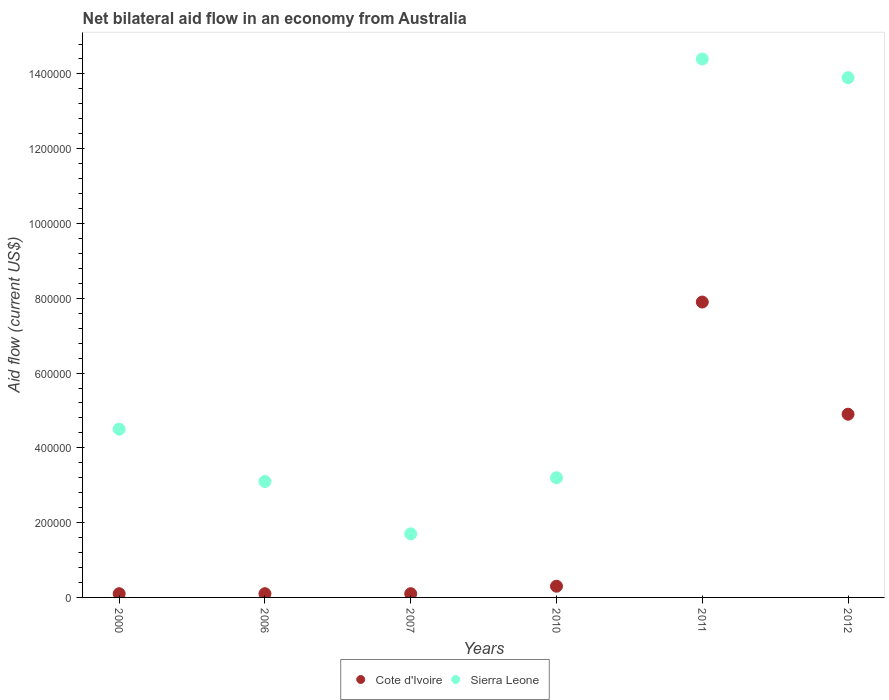Is the number of dotlines equal to the number of legend labels?
Keep it short and to the point. Yes. What is the net bilateral aid flow in Sierra Leone in 2011?
Your answer should be very brief. 1.44e+06. Across all years, what is the maximum net bilateral aid flow in Sierra Leone?
Provide a short and direct response. 1.44e+06. Across all years, what is the minimum net bilateral aid flow in Sierra Leone?
Offer a terse response. 1.70e+05. In which year was the net bilateral aid flow in Cote d'Ivoire maximum?
Offer a very short reply. 2011. What is the total net bilateral aid flow in Sierra Leone in the graph?
Offer a very short reply. 4.08e+06. What is the difference between the net bilateral aid flow in Sierra Leone in 2010 and that in 2011?
Provide a succinct answer. -1.12e+06. What is the difference between the net bilateral aid flow in Sierra Leone in 2010 and the net bilateral aid flow in Cote d'Ivoire in 2007?
Offer a very short reply. 3.10e+05. What is the average net bilateral aid flow in Cote d'Ivoire per year?
Your answer should be compact. 2.23e+05. In how many years, is the net bilateral aid flow in Cote d'Ivoire greater than 1280000 US$?
Provide a succinct answer. 0. What is the ratio of the net bilateral aid flow in Cote d'Ivoire in 2007 to that in 2012?
Ensure brevity in your answer.  0.02. What is the difference between the highest and the second highest net bilateral aid flow in Sierra Leone?
Give a very brief answer. 5.00e+04. What is the difference between the highest and the lowest net bilateral aid flow in Cote d'Ivoire?
Provide a succinct answer. 7.80e+05. Is the net bilateral aid flow in Cote d'Ivoire strictly greater than the net bilateral aid flow in Sierra Leone over the years?
Offer a very short reply. No. How many dotlines are there?
Keep it short and to the point. 2. How many years are there in the graph?
Offer a very short reply. 6. What is the difference between two consecutive major ticks on the Y-axis?
Offer a very short reply. 2.00e+05. Does the graph contain any zero values?
Provide a succinct answer. No. Does the graph contain grids?
Your answer should be compact. No. What is the title of the graph?
Ensure brevity in your answer.  Net bilateral aid flow in an economy from Australia. What is the Aid flow (current US$) in Cote d'Ivoire in 2000?
Offer a very short reply. 10000. What is the Aid flow (current US$) in Cote d'Ivoire in 2006?
Your answer should be very brief. 10000. What is the Aid flow (current US$) of Cote d'Ivoire in 2007?
Ensure brevity in your answer.  10000. What is the Aid flow (current US$) in Cote d'Ivoire in 2010?
Offer a very short reply. 3.00e+04. What is the Aid flow (current US$) in Sierra Leone in 2010?
Offer a terse response. 3.20e+05. What is the Aid flow (current US$) of Cote d'Ivoire in 2011?
Provide a short and direct response. 7.90e+05. What is the Aid flow (current US$) of Sierra Leone in 2011?
Keep it short and to the point. 1.44e+06. What is the Aid flow (current US$) in Cote d'Ivoire in 2012?
Give a very brief answer. 4.90e+05. What is the Aid flow (current US$) of Sierra Leone in 2012?
Offer a terse response. 1.39e+06. Across all years, what is the maximum Aid flow (current US$) of Cote d'Ivoire?
Offer a very short reply. 7.90e+05. Across all years, what is the maximum Aid flow (current US$) in Sierra Leone?
Keep it short and to the point. 1.44e+06. Across all years, what is the minimum Aid flow (current US$) in Sierra Leone?
Offer a terse response. 1.70e+05. What is the total Aid flow (current US$) in Cote d'Ivoire in the graph?
Offer a very short reply. 1.34e+06. What is the total Aid flow (current US$) of Sierra Leone in the graph?
Give a very brief answer. 4.08e+06. What is the difference between the Aid flow (current US$) of Cote d'Ivoire in 2000 and that in 2006?
Provide a succinct answer. 0. What is the difference between the Aid flow (current US$) of Sierra Leone in 2000 and that in 2006?
Offer a very short reply. 1.40e+05. What is the difference between the Aid flow (current US$) in Cote d'Ivoire in 2000 and that in 2007?
Provide a succinct answer. 0. What is the difference between the Aid flow (current US$) of Sierra Leone in 2000 and that in 2010?
Offer a very short reply. 1.30e+05. What is the difference between the Aid flow (current US$) in Cote d'Ivoire in 2000 and that in 2011?
Your answer should be very brief. -7.80e+05. What is the difference between the Aid flow (current US$) in Sierra Leone in 2000 and that in 2011?
Provide a succinct answer. -9.90e+05. What is the difference between the Aid flow (current US$) in Cote d'Ivoire in 2000 and that in 2012?
Give a very brief answer. -4.80e+05. What is the difference between the Aid flow (current US$) of Sierra Leone in 2000 and that in 2012?
Offer a very short reply. -9.40e+05. What is the difference between the Aid flow (current US$) in Cote d'Ivoire in 2006 and that in 2007?
Give a very brief answer. 0. What is the difference between the Aid flow (current US$) of Sierra Leone in 2006 and that in 2007?
Your answer should be compact. 1.40e+05. What is the difference between the Aid flow (current US$) of Cote d'Ivoire in 2006 and that in 2010?
Offer a very short reply. -2.00e+04. What is the difference between the Aid flow (current US$) of Cote d'Ivoire in 2006 and that in 2011?
Ensure brevity in your answer.  -7.80e+05. What is the difference between the Aid flow (current US$) of Sierra Leone in 2006 and that in 2011?
Ensure brevity in your answer.  -1.13e+06. What is the difference between the Aid flow (current US$) of Cote d'Ivoire in 2006 and that in 2012?
Provide a short and direct response. -4.80e+05. What is the difference between the Aid flow (current US$) in Sierra Leone in 2006 and that in 2012?
Your answer should be very brief. -1.08e+06. What is the difference between the Aid flow (current US$) in Cote d'Ivoire in 2007 and that in 2010?
Your answer should be compact. -2.00e+04. What is the difference between the Aid flow (current US$) in Cote d'Ivoire in 2007 and that in 2011?
Your answer should be very brief. -7.80e+05. What is the difference between the Aid flow (current US$) of Sierra Leone in 2007 and that in 2011?
Your response must be concise. -1.27e+06. What is the difference between the Aid flow (current US$) of Cote d'Ivoire in 2007 and that in 2012?
Make the answer very short. -4.80e+05. What is the difference between the Aid flow (current US$) in Sierra Leone in 2007 and that in 2012?
Your response must be concise. -1.22e+06. What is the difference between the Aid flow (current US$) in Cote d'Ivoire in 2010 and that in 2011?
Your answer should be very brief. -7.60e+05. What is the difference between the Aid flow (current US$) of Sierra Leone in 2010 and that in 2011?
Provide a short and direct response. -1.12e+06. What is the difference between the Aid flow (current US$) of Cote d'Ivoire in 2010 and that in 2012?
Keep it short and to the point. -4.60e+05. What is the difference between the Aid flow (current US$) of Sierra Leone in 2010 and that in 2012?
Provide a succinct answer. -1.07e+06. What is the difference between the Aid flow (current US$) in Sierra Leone in 2011 and that in 2012?
Ensure brevity in your answer.  5.00e+04. What is the difference between the Aid flow (current US$) in Cote d'Ivoire in 2000 and the Aid flow (current US$) in Sierra Leone in 2006?
Your answer should be compact. -3.00e+05. What is the difference between the Aid flow (current US$) in Cote d'Ivoire in 2000 and the Aid flow (current US$) in Sierra Leone in 2010?
Your response must be concise. -3.10e+05. What is the difference between the Aid flow (current US$) of Cote d'Ivoire in 2000 and the Aid flow (current US$) of Sierra Leone in 2011?
Give a very brief answer. -1.43e+06. What is the difference between the Aid flow (current US$) of Cote d'Ivoire in 2000 and the Aid flow (current US$) of Sierra Leone in 2012?
Keep it short and to the point. -1.38e+06. What is the difference between the Aid flow (current US$) in Cote d'Ivoire in 2006 and the Aid flow (current US$) in Sierra Leone in 2010?
Your response must be concise. -3.10e+05. What is the difference between the Aid flow (current US$) of Cote d'Ivoire in 2006 and the Aid flow (current US$) of Sierra Leone in 2011?
Offer a very short reply. -1.43e+06. What is the difference between the Aid flow (current US$) of Cote d'Ivoire in 2006 and the Aid flow (current US$) of Sierra Leone in 2012?
Offer a very short reply. -1.38e+06. What is the difference between the Aid flow (current US$) in Cote d'Ivoire in 2007 and the Aid flow (current US$) in Sierra Leone in 2010?
Offer a very short reply. -3.10e+05. What is the difference between the Aid flow (current US$) of Cote d'Ivoire in 2007 and the Aid flow (current US$) of Sierra Leone in 2011?
Keep it short and to the point. -1.43e+06. What is the difference between the Aid flow (current US$) of Cote d'Ivoire in 2007 and the Aid flow (current US$) of Sierra Leone in 2012?
Ensure brevity in your answer.  -1.38e+06. What is the difference between the Aid flow (current US$) in Cote d'Ivoire in 2010 and the Aid flow (current US$) in Sierra Leone in 2011?
Your response must be concise. -1.41e+06. What is the difference between the Aid flow (current US$) in Cote d'Ivoire in 2010 and the Aid flow (current US$) in Sierra Leone in 2012?
Provide a succinct answer. -1.36e+06. What is the difference between the Aid flow (current US$) of Cote d'Ivoire in 2011 and the Aid flow (current US$) of Sierra Leone in 2012?
Offer a very short reply. -6.00e+05. What is the average Aid flow (current US$) of Cote d'Ivoire per year?
Provide a succinct answer. 2.23e+05. What is the average Aid flow (current US$) of Sierra Leone per year?
Provide a short and direct response. 6.80e+05. In the year 2000, what is the difference between the Aid flow (current US$) in Cote d'Ivoire and Aid flow (current US$) in Sierra Leone?
Offer a very short reply. -4.40e+05. In the year 2007, what is the difference between the Aid flow (current US$) in Cote d'Ivoire and Aid flow (current US$) in Sierra Leone?
Your answer should be compact. -1.60e+05. In the year 2011, what is the difference between the Aid flow (current US$) of Cote d'Ivoire and Aid flow (current US$) of Sierra Leone?
Provide a short and direct response. -6.50e+05. In the year 2012, what is the difference between the Aid flow (current US$) in Cote d'Ivoire and Aid flow (current US$) in Sierra Leone?
Offer a very short reply. -9.00e+05. What is the ratio of the Aid flow (current US$) in Sierra Leone in 2000 to that in 2006?
Ensure brevity in your answer.  1.45. What is the ratio of the Aid flow (current US$) of Cote d'Ivoire in 2000 to that in 2007?
Offer a very short reply. 1. What is the ratio of the Aid flow (current US$) of Sierra Leone in 2000 to that in 2007?
Your response must be concise. 2.65. What is the ratio of the Aid flow (current US$) in Cote d'Ivoire in 2000 to that in 2010?
Offer a terse response. 0.33. What is the ratio of the Aid flow (current US$) in Sierra Leone in 2000 to that in 2010?
Your response must be concise. 1.41. What is the ratio of the Aid flow (current US$) in Cote d'Ivoire in 2000 to that in 2011?
Your answer should be very brief. 0.01. What is the ratio of the Aid flow (current US$) in Sierra Leone in 2000 to that in 2011?
Give a very brief answer. 0.31. What is the ratio of the Aid flow (current US$) of Cote d'Ivoire in 2000 to that in 2012?
Your response must be concise. 0.02. What is the ratio of the Aid flow (current US$) in Sierra Leone in 2000 to that in 2012?
Provide a short and direct response. 0.32. What is the ratio of the Aid flow (current US$) of Cote d'Ivoire in 2006 to that in 2007?
Make the answer very short. 1. What is the ratio of the Aid flow (current US$) in Sierra Leone in 2006 to that in 2007?
Provide a short and direct response. 1.82. What is the ratio of the Aid flow (current US$) in Sierra Leone in 2006 to that in 2010?
Your response must be concise. 0.97. What is the ratio of the Aid flow (current US$) in Cote d'Ivoire in 2006 to that in 2011?
Keep it short and to the point. 0.01. What is the ratio of the Aid flow (current US$) of Sierra Leone in 2006 to that in 2011?
Your answer should be compact. 0.22. What is the ratio of the Aid flow (current US$) of Cote d'Ivoire in 2006 to that in 2012?
Give a very brief answer. 0.02. What is the ratio of the Aid flow (current US$) in Sierra Leone in 2006 to that in 2012?
Ensure brevity in your answer.  0.22. What is the ratio of the Aid flow (current US$) in Cote d'Ivoire in 2007 to that in 2010?
Offer a terse response. 0.33. What is the ratio of the Aid flow (current US$) in Sierra Leone in 2007 to that in 2010?
Give a very brief answer. 0.53. What is the ratio of the Aid flow (current US$) of Cote d'Ivoire in 2007 to that in 2011?
Ensure brevity in your answer.  0.01. What is the ratio of the Aid flow (current US$) in Sierra Leone in 2007 to that in 2011?
Offer a terse response. 0.12. What is the ratio of the Aid flow (current US$) in Cote d'Ivoire in 2007 to that in 2012?
Make the answer very short. 0.02. What is the ratio of the Aid flow (current US$) in Sierra Leone in 2007 to that in 2012?
Offer a terse response. 0.12. What is the ratio of the Aid flow (current US$) of Cote d'Ivoire in 2010 to that in 2011?
Provide a succinct answer. 0.04. What is the ratio of the Aid flow (current US$) in Sierra Leone in 2010 to that in 2011?
Provide a succinct answer. 0.22. What is the ratio of the Aid flow (current US$) in Cote d'Ivoire in 2010 to that in 2012?
Provide a succinct answer. 0.06. What is the ratio of the Aid flow (current US$) in Sierra Leone in 2010 to that in 2012?
Ensure brevity in your answer.  0.23. What is the ratio of the Aid flow (current US$) in Cote d'Ivoire in 2011 to that in 2012?
Your answer should be very brief. 1.61. What is the ratio of the Aid flow (current US$) of Sierra Leone in 2011 to that in 2012?
Your answer should be very brief. 1.04. What is the difference between the highest and the second highest Aid flow (current US$) in Cote d'Ivoire?
Offer a terse response. 3.00e+05. What is the difference between the highest and the lowest Aid flow (current US$) in Cote d'Ivoire?
Your answer should be compact. 7.80e+05. What is the difference between the highest and the lowest Aid flow (current US$) of Sierra Leone?
Give a very brief answer. 1.27e+06. 